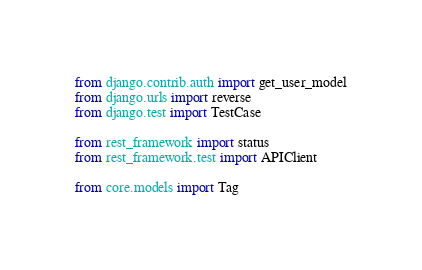<code> <loc_0><loc_0><loc_500><loc_500><_Python_>from django.contrib.auth import get_user_model
from django.urls import reverse
from django.test import TestCase

from rest_framework import status
from rest_framework.test import APIClient

from core.models import Tag
</code> 